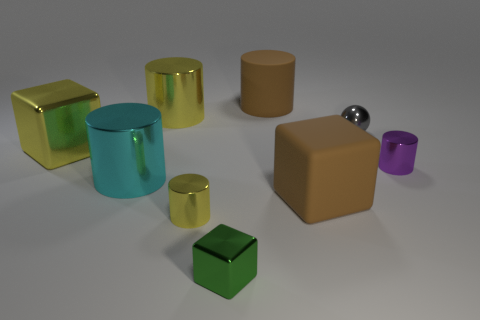Subtract all small metallic cylinders. How many cylinders are left? 3 Subtract all blue spheres. How many yellow cylinders are left? 2 Subtract all yellow cylinders. How many cylinders are left? 3 Add 1 gray things. How many objects exist? 10 Subtract 1 blocks. How many blocks are left? 2 Add 5 tiny gray shiny balls. How many tiny gray shiny balls exist? 6 Subtract 0 blue spheres. How many objects are left? 9 Subtract all blocks. How many objects are left? 6 Subtract all green blocks. Subtract all gray cylinders. How many blocks are left? 2 Subtract all tiny rubber cylinders. Subtract all big yellow cylinders. How many objects are left? 8 